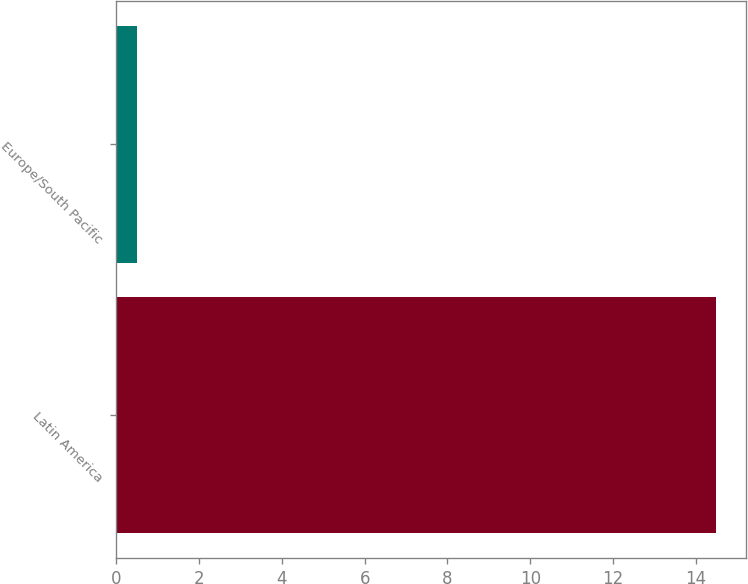Convert chart to OTSL. <chart><loc_0><loc_0><loc_500><loc_500><bar_chart><fcel>Latin America<fcel>Europe/South Pacific<nl><fcel>14.5<fcel>0.5<nl></chart> 